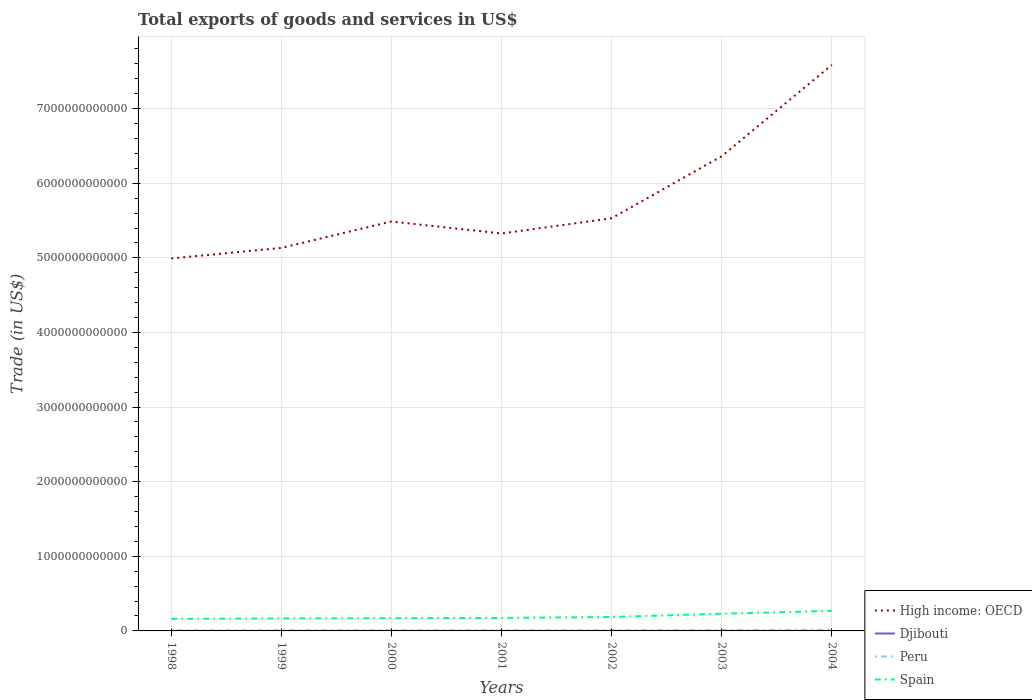Across all years, what is the maximum total exports of goods and services in Peru?
Offer a terse response. 7.54e+09. What is the total total exports of goods and services in Spain in the graph?
Your answer should be compact. -6.36e+1. What is the difference between the highest and the second highest total exports of goods and services in Peru?
Provide a short and direct response. 7.42e+09. What is the difference between the highest and the lowest total exports of goods and services in Djibouti?
Make the answer very short. 3. Is the total exports of goods and services in High income: OECD strictly greater than the total exports of goods and services in Spain over the years?
Offer a terse response. No. What is the difference between two consecutive major ticks on the Y-axis?
Give a very brief answer. 1.00e+12. Does the graph contain any zero values?
Offer a terse response. No. How many legend labels are there?
Provide a short and direct response. 4. What is the title of the graph?
Your response must be concise. Total exports of goods and services in US$. Does "Belize" appear as one of the legend labels in the graph?
Make the answer very short. No. What is the label or title of the Y-axis?
Your answer should be very brief. Trade (in US$). What is the Trade (in US$) of High income: OECD in 1998?
Make the answer very short. 4.99e+12. What is the Trade (in US$) in Djibouti in 1998?
Ensure brevity in your answer.  2.08e+08. What is the Trade (in US$) in Peru in 1998?
Ensure brevity in your answer.  7.54e+09. What is the Trade (in US$) in Spain in 1998?
Your answer should be very brief. 1.62e+11. What is the Trade (in US$) in High income: OECD in 1999?
Provide a succinct answer. 5.13e+12. What is the Trade (in US$) of Djibouti in 1999?
Give a very brief answer. 2.00e+08. What is the Trade (in US$) in Peru in 1999?
Offer a very short reply. 7.64e+09. What is the Trade (in US$) in Spain in 1999?
Provide a short and direct response. 1.67e+11. What is the Trade (in US$) of High income: OECD in 2000?
Provide a succinct answer. 5.49e+12. What is the Trade (in US$) of Djibouti in 2000?
Ensure brevity in your answer.  1.93e+08. What is the Trade (in US$) of Peru in 2000?
Provide a short and direct response. 8.56e+09. What is the Trade (in US$) of Spain in 2000?
Your answer should be very brief. 1.70e+11. What is the Trade (in US$) of High income: OECD in 2001?
Offer a very short reply. 5.33e+12. What is the Trade (in US$) in Djibouti in 2001?
Offer a very short reply. 2.13e+08. What is the Trade (in US$) of Peru in 2001?
Offer a very short reply. 8.50e+09. What is the Trade (in US$) in Spain in 2001?
Ensure brevity in your answer.  1.74e+11. What is the Trade (in US$) of High income: OECD in 2002?
Offer a very short reply. 5.53e+12. What is the Trade (in US$) of Djibouti in 2002?
Provide a short and direct response. 2.28e+08. What is the Trade (in US$) in Peru in 2002?
Your response must be concise. 9.29e+09. What is the Trade (in US$) of Spain in 2002?
Give a very brief answer. 1.87e+11. What is the Trade (in US$) in High income: OECD in 2003?
Ensure brevity in your answer.  6.36e+12. What is the Trade (in US$) of Djibouti in 2003?
Offer a very short reply. 2.48e+08. What is the Trade (in US$) in Peru in 2003?
Keep it short and to the point. 1.09e+1. What is the Trade (in US$) of Spain in 2003?
Your answer should be very brief. 2.31e+11. What is the Trade (in US$) in High income: OECD in 2004?
Give a very brief answer. 7.59e+12. What is the Trade (in US$) in Djibouti in 2004?
Offer a very short reply. 2.46e+08. What is the Trade (in US$) of Peru in 2004?
Ensure brevity in your answer.  1.50e+1. What is the Trade (in US$) in Spain in 2004?
Ensure brevity in your answer.  2.69e+11. Across all years, what is the maximum Trade (in US$) of High income: OECD?
Offer a very short reply. 7.59e+12. Across all years, what is the maximum Trade (in US$) of Djibouti?
Your response must be concise. 2.48e+08. Across all years, what is the maximum Trade (in US$) of Peru?
Your answer should be compact. 1.50e+1. Across all years, what is the maximum Trade (in US$) of Spain?
Your answer should be compact. 2.69e+11. Across all years, what is the minimum Trade (in US$) in High income: OECD?
Your answer should be compact. 4.99e+12. Across all years, what is the minimum Trade (in US$) of Djibouti?
Give a very brief answer. 1.93e+08. Across all years, what is the minimum Trade (in US$) in Peru?
Your response must be concise. 7.54e+09. Across all years, what is the minimum Trade (in US$) of Spain?
Provide a succinct answer. 1.62e+11. What is the total Trade (in US$) of High income: OECD in the graph?
Offer a very short reply. 4.04e+13. What is the total Trade (in US$) of Djibouti in the graph?
Offer a terse response. 1.54e+09. What is the total Trade (in US$) of Peru in the graph?
Your answer should be compact. 6.74e+1. What is the total Trade (in US$) of Spain in the graph?
Offer a very short reply. 1.36e+12. What is the difference between the Trade (in US$) in High income: OECD in 1998 and that in 1999?
Give a very brief answer. -1.42e+11. What is the difference between the Trade (in US$) of Djibouti in 1998 and that in 1999?
Give a very brief answer. 7.96e+06. What is the difference between the Trade (in US$) of Peru in 1998 and that in 1999?
Provide a short and direct response. -1.03e+08. What is the difference between the Trade (in US$) of Spain in 1998 and that in 1999?
Keep it short and to the point. -5.58e+09. What is the difference between the Trade (in US$) of High income: OECD in 1998 and that in 2000?
Offer a very short reply. -4.95e+11. What is the difference between the Trade (in US$) in Djibouti in 1998 and that in 2000?
Your answer should be compact. 1.48e+07. What is the difference between the Trade (in US$) of Peru in 1998 and that in 2000?
Your response must be concise. -1.02e+09. What is the difference between the Trade (in US$) of Spain in 1998 and that in 2000?
Give a very brief answer. -8.82e+09. What is the difference between the Trade (in US$) of High income: OECD in 1998 and that in 2001?
Give a very brief answer. -3.35e+11. What is the difference between the Trade (in US$) in Djibouti in 1998 and that in 2001?
Provide a short and direct response. -5.49e+06. What is the difference between the Trade (in US$) in Peru in 1998 and that in 2001?
Offer a very short reply. -9.64e+08. What is the difference between the Trade (in US$) of Spain in 1998 and that in 2001?
Offer a very short reply. -1.28e+1. What is the difference between the Trade (in US$) in High income: OECD in 1998 and that in 2002?
Your answer should be very brief. -5.39e+11. What is the difference between the Trade (in US$) in Djibouti in 1998 and that in 2002?
Provide a short and direct response. -2.00e+07. What is the difference between the Trade (in US$) in Peru in 1998 and that in 2002?
Ensure brevity in your answer.  -1.75e+09. What is the difference between the Trade (in US$) in Spain in 1998 and that in 2002?
Keep it short and to the point. -2.51e+1. What is the difference between the Trade (in US$) in High income: OECD in 1998 and that in 2003?
Offer a very short reply. -1.37e+12. What is the difference between the Trade (in US$) in Djibouti in 1998 and that in 2003?
Offer a terse response. -4.03e+07. What is the difference between the Trade (in US$) in Peru in 1998 and that in 2003?
Your response must be concise. -3.40e+09. What is the difference between the Trade (in US$) of Spain in 1998 and that in 2003?
Offer a terse response. -6.92e+1. What is the difference between the Trade (in US$) in High income: OECD in 1998 and that in 2004?
Make the answer very short. -2.59e+12. What is the difference between the Trade (in US$) in Djibouti in 1998 and that in 2004?
Your response must be concise. -3.83e+07. What is the difference between the Trade (in US$) of Peru in 1998 and that in 2004?
Offer a terse response. -7.42e+09. What is the difference between the Trade (in US$) in Spain in 1998 and that in 2004?
Your answer should be very brief. -1.08e+11. What is the difference between the Trade (in US$) of High income: OECD in 1999 and that in 2000?
Make the answer very short. -3.53e+11. What is the difference between the Trade (in US$) of Djibouti in 1999 and that in 2000?
Offer a terse response. 6.80e+06. What is the difference between the Trade (in US$) of Peru in 1999 and that in 2000?
Ensure brevity in your answer.  -9.19e+08. What is the difference between the Trade (in US$) of Spain in 1999 and that in 2000?
Give a very brief answer. -3.24e+09. What is the difference between the Trade (in US$) of High income: OECD in 1999 and that in 2001?
Provide a succinct answer. -1.93e+11. What is the difference between the Trade (in US$) of Djibouti in 1999 and that in 2001?
Keep it short and to the point. -1.34e+07. What is the difference between the Trade (in US$) of Peru in 1999 and that in 2001?
Ensure brevity in your answer.  -8.61e+08. What is the difference between the Trade (in US$) of Spain in 1999 and that in 2001?
Your answer should be very brief. -7.26e+09. What is the difference between the Trade (in US$) in High income: OECD in 1999 and that in 2002?
Keep it short and to the point. -3.97e+11. What is the difference between the Trade (in US$) of Djibouti in 1999 and that in 2002?
Make the answer very short. -2.80e+07. What is the difference between the Trade (in US$) in Peru in 1999 and that in 2002?
Provide a succinct answer. -1.65e+09. What is the difference between the Trade (in US$) of Spain in 1999 and that in 2002?
Your answer should be very brief. -1.96e+1. What is the difference between the Trade (in US$) in High income: OECD in 1999 and that in 2003?
Provide a succinct answer. -1.23e+12. What is the difference between the Trade (in US$) of Djibouti in 1999 and that in 2003?
Your answer should be compact. -4.82e+07. What is the difference between the Trade (in US$) of Peru in 1999 and that in 2003?
Ensure brevity in your answer.  -3.30e+09. What is the difference between the Trade (in US$) in Spain in 1999 and that in 2003?
Provide a succinct answer. -6.36e+1. What is the difference between the Trade (in US$) of High income: OECD in 1999 and that in 2004?
Provide a short and direct response. -2.45e+12. What is the difference between the Trade (in US$) in Djibouti in 1999 and that in 2004?
Provide a short and direct response. -4.62e+07. What is the difference between the Trade (in US$) of Peru in 1999 and that in 2004?
Offer a terse response. -7.31e+09. What is the difference between the Trade (in US$) of Spain in 1999 and that in 2004?
Your response must be concise. -1.02e+11. What is the difference between the Trade (in US$) in High income: OECD in 2000 and that in 2001?
Your answer should be very brief. 1.60e+11. What is the difference between the Trade (in US$) in Djibouti in 2000 and that in 2001?
Give a very brief answer. -2.02e+07. What is the difference between the Trade (in US$) in Peru in 2000 and that in 2001?
Give a very brief answer. 5.79e+07. What is the difference between the Trade (in US$) in Spain in 2000 and that in 2001?
Offer a terse response. -4.03e+09. What is the difference between the Trade (in US$) in High income: OECD in 2000 and that in 2002?
Your response must be concise. -4.33e+1. What is the difference between the Trade (in US$) in Djibouti in 2000 and that in 2002?
Give a very brief answer. -3.48e+07. What is the difference between the Trade (in US$) of Peru in 2000 and that in 2002?
Give a very brief answer. -7.33e+08. What is the difference between the Trade (in US$) in Spain in 2000 and that in 2002?
Offer a terse response. -1.63e+1. What is the difference between the Trade (in US$) of High income: OECD in 2000 and that in 2003?
Give a very brief answer. -8.75e+11. What is the difference between the Trade (in US$) in Djibouti in 2000 and that in 2003?
Your answer should be very brief. -5.50e+07. What is the difference between the Trade (in US$) of Peru in 2000 and that in 2003?
Your answer should be very brief. -2.38e+09. What is the difference between the Trade (in US$) of Spain in 2000 and that in 2003?
Offer a terse response. -6.04e+1. What is the difference between the Trade (in US$) in High income: OECD in 2000 and that in 2004?
Make the answer very short. -2.10e+12. What is the difference between the Trade (in US$) of Djibouti in 2000 and that in 2004?
Provide a short and direct response. -5.30e+07. What is the difference between the Trade (in US$) of Peru in 2000 and that in 2004?
Offer a terse response. -6.39e+09. What is the difference between the Trade (in US$) in Spain in 2000 and that in 2004?
Offer a terse response. -9.89e+1. What is the difference between the Trade (in US$) of High income: OECD in 2001 and that in 2002?
Ensure brevity in your answer.  -2.04e+11. What is the difference between the Trade (in US$) in Djibouti in 2001 and that in 2002?
Offer a terse response. -1.45e+07. What is the difference between the Trade (in US$) in Peru in 2001 and that in 2002?
Your response must be concise. -7.90e+08. What is the difference between the Trade (in US$) of Spain in 2001 and that in 2002?
Your response must be concise. -1.23e+1. What is the difference between the Trade (in US$) in High income: OECD in 2001 and that in 2003?
Your response must be concise. -1.04e+12. What is the difference between the Trade (in US$) in Djibouti in 2001 and that in 2003?
Ensure brevity in your answer.  -3.48e+07. What is the difference between the Trade (in US$) of Peru in 2001 and that in 2003?
Your answer should be compact. -2.44e+09. What is the difference between the Trade (in US$) of Spain in 2001 and that in 2003?
Keep it short and to the point. -5.64e+1. What is the difference between the Trade (in US$) in High income: OECD in 2001 and that in 2004?
Offer a terse response. -2.26e+12. What is the difference between the Trade (in US$) of Djibouti in 2001 and that in 2004?
Ensure brevity in your answer.  -3.28e+07. What is the difference between the Trade (in US$) of Peru in 2001 and that in 2004?
Offer a very short reply. -6.45e+09. What is the difference between the Trade (in US$) of Spain in 2001 and that in 2004?
Keep it short and to the point. -9.49e+1. What is the difference between the Trade (in US$) of High income: OECD in 2002 and that in 2003?
Give a very brief answer. -8.32e+11. What is the difference between the Trade (in US$) of Djibouti in 2002 and that in 2003?
Ensure brevity in your answer.  -2.03e+07. What is the difference between the Trade (in US$) in Peru in 2002 and that in 2003?
Provide a succinct answer. -1.65e+09. What is the difference between the Trade (in US$) of Spain in 2002 and that in 2003?
Make the answer very short. -4.41e+1. What is the difference between the Trade (in US$) of High income: OECD in 2002 and that in 2004?
Ensure brevity in your answer.  -2.06e+12. What is the difference between the Trade (in US$) of Djibouti in 2002 and that in 2004?
Your answer should be very brief. -1.82e+07. What is the difference between the Trade (in US$) in Peru in 2002 and that in 2004?
Give a very brief answer. -5.66e+09. What is the difference between the Trade (in US$) in Spain in 2002 and that in 2004?
Give a very brief answer. -8.26e+1. What is the difference between the Trade (in US$) in High income: OECD in 2003 and that in 2004?
Your answer should be very brief. -1.22e+12. What is the difference between the Trade (in US$) in Djibouti in 2003 and that in 2004?
Your answer should be compact. 2.02e+06. What is the difference between the Trade (in US$) of Peru in 2003 and that in 2004?
Offer a terse response. -4.01e+09. What is the difference between the Trade (in US$) in Spain in 2003 and that in 2004?
Ensure brevity in your answer.  -3.85e+1. What is the difference between the Trade (in US$) in High income: OECD in 1998 and the Trade (in US$) in Djibouti in 1999?
Your response must be concise. 4.99e+12. What is the difference between the Trade (in US$) of High income: OECD in 1998 and the Trade (in US$) of Peru in 1999?
Your answer should be very brief. 4.98e+12. What is the difference between the Trade (in US$) in High income: OECD in 1998 and the Trade (in US$) in Spain in 1999?
Offer a very short reply. 4.82e+12. What is the difference between the Trade (in US$) in Djibouti in 1998 and the Trade (in US$) in Peru in 1999?
Provide a succinct answer. -7.43e+09. What is the difference between the Trade (in US$) of Djibouti in 1998 and the Trade (in US$) of Spain in 1999?
Provide a short and direct response. -1.67e+11. What is the difference between the Trade (in US$) in Peru in 1998 and the Trade (in US$) in Spain in 1999?
Provide a short and direct response. -1.60e+11. What is the difference between the Trade (in US$) in High income: OECD in 1998 and the Trade (in US$) in Djibouti in 2000?
Offer a terse response. 4.99e+12. What is the difference between the Trade (in US$) of High income: OECD in 1998 and the Trade (in US$) of Peru in 2000?
Your answer should be very brief. 4.98e+12. What is the difference between the Trade (in US$) in High income: OECD in 1998 and the Trade (in US$) in Spain in 2000?
Provide a short and direct response. 4.82e+12. What is the difference between the Trade (in US$) in Djibouti in 1998 and the Trade (in US$) in Peru in 2000?
Offer a very short reply. -8.35e+09. What is the difference between the Trade (in US$) in Djibouti in 1998 and the Trade (in US$) in Spain in 2000?
Give a very brief answer. -1.70e+11. What is the difference between the Trade (in US$) in Peru in 1998 and the Trade (in US$) in Spain in 2000?
Offer a terse response. -1.63e+11. What is the difference between the Trade (in US$) of High income: OECD in 1998 and the Trade (in US$) of Djibouti in 2001?
Provide a short and direct response. 4.99e+12. What is the difference between the Trade (in US$) in High income: OECD in 1998 and the Trade (in US$) in Peru in 2001?
Give a very brief answer. 4.98e+12. What is the difference between the Trade (in US$) of High income: OECD in 1998 and the Trade (in US$) of Spain in 2001?
Ensure brevity in your answer.  4.82e+12. What is the difference between the Trade (in US$) in Djibouti in 1998 and the Trade (in US$) in Peru in 2001?
Keep it short and to the point. -8.29e+09. What is the difference between the Trade (in US$) of Djibouti in 1998 and the Trade (in US$) of Spain in 2001?
Ensure brevity in your answer.  -1.74e+11. What is the difference between the Trade (in US$) of Peru in 1998 and the Trade (in US$) of Spain in 2001?
Keep it short and to the point. -1.67e+11. What is the difference between the Trade (in US$) of High income: OECD in 1998 and the Trade (in US$) of Djibouti in 2002?
Ensure brevity in your answer.  4.99e+12. What is the difference between the Trade (in US$) of High income: OECD in 1998 and the Trade (in US$) of Peru in 2002?
Make the answer very short. 4.98e+12. What is the difference between the Trade (in US$) in High income: OECD in 1998 and the Trade (in US$) in Spain in 2002?
Your answer should be very brief. 4.80e+12. What is the difference between the Trade (in US$) in Djibouti in 1998 and the Trade (in US$) in Peru in 2002?
Your answer should be compact. -9.08e+09. What is the difference between the Trade (in US$) in Djibouti in 1998 and the Trade (in US$) in Spain in 2002?
Ensure brevity in your answer.  -1.86e+11. What is the difference between the Trade (in US$) in Peru in 1998 and the Trade (in US$) in Spain in 2002?
Your response must be concise. -1.79e+11. What is the difference between the Trade (in US$) of High income: OECD in 1998 and the Trade (in US$) of Djibouti in 2003?
Your answer should be very brief. 4.99e+12. What is the difference between the Trade (in US$) of High income: OECD in 1998 and the Trade (in US$) of Peru in 2003?
Make the answer very short. 4.98e+12. What is the difference between the Trade (in US$) of High income: OECD in 1998 and the Trade (in US$) of Spain in 2003?
Offer a very short reply. 4.76e+12. What is the difference between the Trade (in US$) in Djibouti in 1998 and the Trade (in US$) in Peru in 2003?
Ensure brevity in your answer.  -1.07e+1. What is the difference between the Trade (in US$) in Djibouti in 1998 and the Trade (in US$) in Spain in 2003?
Give a very brief answer. -2.31e+11. What is the difference between the Trade (in US$) in Peru in 1998 and the Trade (in US$) in Spain in 2003?
Offer a terse response. -2.23e+11. What is the difference between the Trade (in US$) in High income: OECD in 1998 and the Trade (in US$) in Djibouti in 2004?
Offer a terse response. 4.99e+12. What is the difference between the Trade (in US$) of High income: OECD in 1998 and the Trade (in US$) of Peru in 2004?
Make the answer very short. 4.98e+12. What is the difference between the Trade (in US$) in High income: OECD in 1998 and the Trade (in US$) in Spain in 2004?
Provide a succinct answer. 4.72e+12. What is the difference between the Trade (in US$) in Djibouti in 1998 and the Trade (in US$) in Peru in 2004?
Offer a very short reply. -1.47e+1. What is the difference between the Trade (in US$) in Djibouti in 1998 and the Trade (in US$) in Spain in 2004?
Keep it short and to the point. -2.69e+11. What is the difference between the Trade (in US$) of Peru in 1998 and the Trade (in US$) of Spain in 2004?
Provide a succinct answer. -2.62e+11. What is the difference between the Trade (in US$) of High income: OECD in 1999 and the Trade (in US$) of Djibouti in 2000?
Keep it short and to the point. 5.13e+12. What is the difference between the Trade (in US$) of High income: OECD in 1999 and the Trade (in US$) of Peru in 2000?
Keep it short and to the point. 5.13e+12. What is the difference between the Trade (in US$) of High income: OECD in 1999 and the Trade (in US$) of Spain in 2000?
Give a very brief answer. 4.96e+12. What is the difference between the Trade (in US$) of Djibouti in 1999 and the Trade (in US$) of Peru in 2000?
Offer a very short reply. -8.36e+09. What is the difference between the Trade (in US$) of Djibouti in 1999 and the Trade (in US$) of Spain in 2000?
Keep it short and to the point. -1.70e+11. What is the difference between the Trade (in US$) in Peru in 1999 and the Trade (in US$) in Spain in 2000?
Keep it short and to the point. -1.63e+11. What is the difference between the Trade (in US$) in High income: OECD in 1999 and the Trade (in US$) in Djibouti in 2001?
Offer a very short reply. 5.13e+12. What is the difference between the Trade (in US$) in High income: OECD in 1999 and the Trade (in US$) in Peru in 2001?
Your answer should be very brief. 5.13e+12. What is the difference between the Trade (in US$) in High income: OECD in 1999 and the Trade (in US$) in Spain in 2001?
Provide a short and direct response. 4.96e+12. What is the difference between the Trade (in US$) in Djibouti in 1999 and the Trade (in US$) in Peru in 2001?
Ensure brevity in your answer.  -8.30e+09. What is the difference between the Trade (in US$) in Djibouti in 1999 and the Trade (in US$) in Spain in 2001?
Your answer should be very brief. -1.74e+11. What is the difference between the Trade (in US$) in Peru in 1999 and the Trade (in US$) in Spain in 2001?
Give a very brief answer. -1.67e+11. What is the difference between the Trade (in US$) in High income: OECD in 1999 and the Trade (in US$) in Djibouti in 2002?
Provide a succinct answer. 5.13e+12. What is the difference between the Trade (in US$) of High income: OECD in 1999 and the Trade (in US$) of Peru in 2002?
Offer a terse response. 5.12e+12. What is the difference between the Trade (in US$) in High income: OECD in 1999 and the Trade (in US$) in Spain in 2002?
Your answer should be compact. 4.95e+12. What is the difference between the Trade (in US$) in Djibouti in 1999 and the Trade (in US$) in Peru in 2002?
Keep it short and to the point. -9.09e+09. What is the difference between the Trade (in US$) in Djibouti in 1999 and the Trade (in US$) in Spain in 2002?
Your response must be concise. -1.87e+11. What is the difference between the Trade (in US$) in Peru in 1999 and the Trade (in US$) in Spain in 2002?
Give a very brief answer. -1.79e+11. What is the difference between the Trade (in US$) in High income: OECD in 1999 and the Trade (in US$) in Djibouti in 2003?
Your response must be concise. 5.13e+12. What is the difference between the Trade (in US$) in High income: OECD in 1999 and the Trade (in US$) in Peru in 2003?
Make the answer very short. 5.12e+12. What is the difference between the Trade (in US$) in High income: OECD in 1999 and the Trade (in US$) in Spain in 2003?
Ensure brevity in your answer.  4.90e+12. What is the difference between the Trade (in US$) in Djibouti in 1999 and the Trade (in US$) in Peru in 2003?
Make the answer very short. -1.07e+1. What is the difference between the Trade (in US$) in Djibouti in 1999 and the Trade (in US$) in Spain in 2003?
Provide a succinct answer. -2.31e+11. What is the difference between the Trade (in US$) of Peru in 1999 and the Trade (in US$) of Spain in 2003?
Offer a terse response. -2.23e+11. What is the difference between the Trade (in US$) of High income: OECD in 1999 and the Trade (in US$) of Djibouti in 2004?
Give a very brief answer. 5.13e+12. What is the difference between the Trade (in US$) of High income: OECD in 1999 and the Trade (in US$) of Peru in 2004?
Keep it short and to the point. 5.12e+12. What is the difference between the Trade (in US$) in High income: OECD in 1999 and the Trade (in US$) in Spain in 2004?
Keep it short and to the point. 4.86e+12. What is the difference between the Trade (in US$) in Djibouti in 1999 and the Trade (in US$) in Peru in 2004?
Give a very brief answer. -1.48e+1. What is the difference between the Trade (in US$) of Djibouti in 1999 and the Trade (in US$) of Spain in 2004?
Give a very brief answer. -2.69e+11. What is the difference between the Trade (in US$) of Peru in 1999 and the Trade (in US$) of Spain in 2004?
Keep it short and to the point. -2.62e+11. What is the difference between the Trade (in US$) in High income: OECD in 2000 and the Trade (in US$) in Djibouti in 2001?
Ensure brevity in your answer.  5.49e+12. What is the difference between the Trade (in US$) in High income: OECD in 2000 and the Trade (in US$) in Peru in 2001?
Your answer should be compact. 5.48e+12. What is the difference between the Trade (in US$) in High income: OECD in 2000 and the Trade (in US$) in Spain in 2001?
Offer a very short reply. 5.31e+12. What is the difference between the Trade (in US$) in Djibouti in 2000 and the Trade (in US$) in Peru in 2001?
Your response must be concise. -8.31e+09. What is the difference between the Trade (in US$) in Djibouti in 2000 and the Trade (in US$) in Spain in 2001?
Provide a short and direct response. -1.74e+11. What is the difference between the Trade (in US$) in Peru in 2000 and the Trade (in US$) in Spain in 2001?
Provide a short and direct response. -1.66e+11. What is the difference between the Trade (in US$) of High income: OECD in 2000 and the Trade (in US$) of Djibouti in 2002?
Offer a terse response. 5.49e+12. What is the difference between the Trade (in US$) of High income: OECD in 2000 and the Trade (in US$) of Peru in 2002?
Offer a very short reply. 5.48e+12. What is the difference between the Trade (in US$) of High income: OECD in 2000 and the Trade (in US$) of Spain in 2002?
Offer a very short reply. 5.30e+12. What is the difference between the Trade (in US$) of Djibouti in 2000 and the Trade (in US$) of Peru in 2002?
Your answer should be compact. -9.10e+09. What is the difference between the Trade (in US$) in Djibouti in 2000 and the Trade (in US$) in Spain in 2002?
Your answer should be compact. -1.87e+11. What is the difference between the Trade (in US$) in Peru in 2000 and the Trade (in US$) in Spain in 2002?
Keep it short and to the point. -1.78e+11. What is the difference between the Trade (in US$) in High income: OECD in 2000 and the Trade (in US$) in Djibouti in 2003?
Your answer should be very brief. 5.49e+12. What is the difference between the Trade (in US$) of High income: OECD in 2000 and the Trade (in US$) of Peru in 2003?
Provide a succinct answer. 5.48e+12. What is the difference between the Trade (in US$) in High income: OECD in 2000 and the Trade (in US$) in Spain in 2003?
Offer a terse response. 5.26e+12. What is the difference between the Trade (in US$) in Djibouti in 2000 and the Trade (in US$) in Peru in 2003?
Provide a succinct answer. -1.07e+1. What is the difference between the Trade (in US$) in Djibouti in 2000 and the Trade (in US$) in Spain in 2003?
Give a very brief answer. -2.31e+11. What is the difference between the Trade (in US$) in Peru in 2000 and the Trade (in US$) in Spain in 2003?
Ensure brevity in your answer.  -2.22e+11. What is the difference between the Trade (in US$) of High income: OECD in 2000 and the Trade (in US$) of Djibouti in 2004?
Offer a very short reply. 5.49e+12. What is the difference between the Trade (in US$) of High income: OECD in 2000 and the Trade (in US$) of Peru in 2004?
Your answer should be compact. 5.47e+12. What is the difference between the Trade (in US$) in High income: OECD in 2000 and the Trade (in US$) in Spain in 2004?
Your response must be concise. 5.22e+12. What is the difference between the Trade (in US$) in Djibouti in 2000 and the Trade (in US$) in Peru in 2004?
Your response must be concise. -1.48e+1. What is the difference between the Trade (in US$) of Djibouti in 2000 and the Trade (in US$) of Spain in 2004?
Your answer should be compact. -2.69e+11. What is the difference between the Trade (in US$) of Peru in 2000 and the Trade (in US$) of Spain in 2004?
Give a very brief answer. -2.61e+11. What is the difference between the Trade (in US$) in High income: OECD in 2001 and the Trade (in US$) in Djibouti in 2002?
Provide a succinct answer. 5.33e+12. What is the difference between the Trade (in US$) in High income: OECD in 2001 and the Trade (in US$) in Peru in 2002?
Your answer should be compact. 5.32e+12. What is the difference between the Trade (in US$) in High income: OECD in 2001 and the Trade (in US$) in Spain in 2002?
Your response must be concise. 5.14e+12. What is the difference between the Trade (in US$) in Djibouti in 2001 and the Trade (in US$) in Peru in 2002?
Make the answer very short. -9.08e+09. What is the difference between the Trade (in US$) in Djibouti in 2001 and the Trade (in US$) in Spain in 2002?
Offer a very short reply. -1.86e+11. What is the difference between the Trade (in US$) in Peru in 2001 and the Trade (in US$) in Spain in 2002?
Your answer should be very brief. -1.78e+11. What is the difference between the Trade (in US$) of High income: OECD in 2001 and the Trade (in US$) of Djibouti in 2003?
Offer a very short reply. 5.33e+12. What is the difference between the Trade (in US$) of High income: OECD in 2001 and the Trade (in US$) of Peru in 2003?
Make the answer very short. 5.32e+12. What is the difference between the Trade (in US$) of High income: OECD in 2001 and the Trade (in US$) of Spain in 2003?
Provide a succinct answer. 5.10e+12. What is the difference between the Trade (in US$) of Djibouti in 2001 and the Trade (in US$) of Peru in 2003?
Give a very brief answer. -1.07e+1. What is the difference between the Trade (in US$) of Djibouti in 2001 and the Trade (in US$) of Spain in 2003?
Provide a succinct answer. -2.31e+11. What is the difference between the Trade (in US$) in Peru in 2001 and the Trade (in US$) in Spain in 2003?
Your answer should be compact. -2.22e+11. What is the difference between the Trade (in US$) in High income: OECD in 2001 and the Trade (in US$) in Djibouti in 2004?
Provide a short and direct response. 5.33e+12. What is the difference between the Trade (in US$) in High income: OECD in 2001 and the Trade (in US$) in Peru in 2004?
Provide a short and direct response. 5.31e+12. What is the difference between the Trade (in US$) of High income: OECD in 2001 and the Trade (in US$) of Spain in 2004?
Your answer should be compact. 5.06e+12. What is the difference between the Trade (in US$) in Djibouti in 2001 and the Trade (in US$) in Peru in 2004?
Offer a very short reply. -1.47e+1. What is the difference between the Trade (in US$) of Djibouti in 2001 and the Trade (in US$) of Spain in 2004?
Provide a short and direct response. -2.69e+11. What is the difference between the Trade (in US$) in Peru in 2001 and the Trade (in US$) in Spain in 2004?
Your response must be concise. -2.61e+11. What is the difference between the Trade (in US$) in High income: OECD in 2002 and the Trade (in US$) in Djibouti in 2003?
Your response must be concise. 5.53e+12. What is the difference between the Trade (in US$) of High income: OECD in 2002 and the Trade (in US$) of Peru in 2003?
Your response must be concise. 5.52e+12. What is the difference between the Trade (in US$) of High income: OECD in 2002 and the Trade (in US$) of Spain in 2003?
Ensure brevity in your answer.  5.30e+12. What is the difference between the Trade (in US$) in Djibouti in 2002 and the Trade (in US$) in Peru in 2003?
Your answer should be compact. -1.07e+1. What is the difference between the Trade (in US$) in Djibouti in 2002 and the Trade (in US$) in Spain in 2003?
Keep it short and to the point. -2.31e+11. What is the difference between the Trade (in US$) of Peru in 2002 and the Trade (in US$) of Spain in 2003?
Your response must be concise. -2.21e+11. What is the difference between the Trade (in US$) of High income: OECD in 2002 and the Trade (in US$) of Djibouti in 2004?
Give a very brief answer. 5.53e+12. What is the difference between the Trade (in US$) of High income: OECD in 2002 and the Trade (in US$) of Peru in 2004?
Make the answer very short. 5.52e+12. What is the difference between the Trade (in US$) of High income: OECD in 2002 and the Trade (in US$) of Spain in 2004?
Provide a succinct answer. 5.26e+12. What is the difference between the Trade (in US$) of Djibouti in 2002 and the Trade (in US$) of Peru in 2004?
Your answer should be very brief. -1.47e+1. What is the difference between the Trade (in US$) of Djibouti in 2002 and the Trade (in US$) of Spain in 2004?
Offer a very short reply. -2.69e+11. What is the difference between the Trade (in US$) in Peru in 2002 and the Trade (in US$) in Spain in 2004?
Make the answer very short. -2.60e+11. What is the difference between the Trade (in US$) of High income: OECD in 2003 and the Trade (in US$) of Djibouti in 2004?
Your answer should be compact. 6.36e+12. What is the difference between the Trade (in US$) of High income: OECD in 2003 and the Trade (in US$) of Peru in 2004?
Keep it short and to the point. 6.35e+12. What is the difference between the Trade (in US$) in High income: OECD in 2003 and the Trade (in US$) in Spain in 2004?
Ensure brevity in your answer.  6.09e+12. What is the difference between the Trade (in US$) of Djibouti in 2003 and the Trade (in US$) of Peru in 2004?
Make the answer very short. -1.47e+1. What is the difference between the Trade (in US$) of Djibouti in 2003 and the Trade (in US$) of Spain in 2004?
Offer a very short reply. -2.69e+11. What is the difference between the Trade (in US$) in Peru in 2003 and the Trade (in US$) in Spain in 2004?
Provide a short and direct response. -2.58e+11. What is the average Trade (in US$) of High income: OECD per year?
Give a very brief answer. 5.77e+12. What is the average Trade (in US$) of Djibouti per year?
Offer a very short reply. 2.20e+08. What is the average Trade (in US$) in Peru per year?
Keep it short and to the point. 9.63e+09. What is the average Trade (in US$) of Spain per year?
Offer a very short reply. 1.94e+11. In the year 1998, what is the difference between the Trade (in US$) of High income: OECD and Trade (in US$) of Djibouti?
Ensure brevity in your answer.  4.99e+12. In the year 1998, what is the difference between the Trade (in US$) of High income: OECD and Trade (in US$) of Peru?
Your answer should be compact. 4.98e+12. In the year 1998, what is the difference between the Trade (in US$) of High income: OECD and Trade (in US$) of Spain?
Provide a succinct answer. 4.83e+12. In the year 1998, what is the difference between the Trade (in US$) in Djibouti and Trade (in US$) in Peru?
Offer a very short reply. -7.33e+09. In the year 1998, what is the difference between the Trade (in US$) of Djibouti and Trade (in US$) of Spain?
Your answer should be compact. -1.61e+11. In the year 1998, what is the difference between the Trade (in US$) in Peru and Trade (in US$) in Spain?
Provide a succinct answer. -1.54e+11. In the year 1999, what is the difference between the Trade (in US$) in High income: OECD and Trade (in US$) in Djibouti?
Make the answer very short. 5.13e+12. In the year 1999, what is the difference between the Trade (in US$) of High income: OECD and Trade (in US$) of Peru?
Ensure brevity in your answer.  5.13e+12. In the year 1999, what is the difference between the Trade (in US$) in High income: OECD and Trade (in US$) in Spain?
Offer a terse response. 4.97e+12. In the year 1999, what is the difference between the Trade (in US$) of Djibouti and Trade (in US$) of Peru?
Make the answer very short. -7.44e+09. In the year 1999, what is the difference between the Trade (in US$) in Djibouti and Trade (in US$) in Spain?
Offer a terse response. -1.67e+11. In the year 1999, what is the difference between the Trade (in US$) of Peru and Trade (in US$) of Spain?
Offer a terse response. -1.60e+11. In the year 2000, what is the difference between the Trade (in US$) in High income: OECD and Trade (in US$) in Djibouti?
Make the answer very short. 5.49e+12. In the year 2000, what is the difference between the Trade (in US$) of High income: OECD and Trade (in US$) of Peru?
Your response must be concise. 5.48e+12. In the year 2000, what is the difference between the Trade (in US$) in High income: OECD and Trade (in US$) in Spain?
Provide a succinct answer. 5.32e+12. In the year 2000, what is the difference between the Trade (in US$) in Djibouti and Trade (in US$) in Peru?
Your answer should be compact. -8.36e+09. In the year 2000, what is the difference between the Trade (in US$) in Djibouti and Trade (in US$) in Spain?
Your answer should be very brief. -1.70e+11. In the year 2000, what is the difference between the Trade (in US$) in Peru and Trade (in US$) in Spain?
Your response must be concise. -1.62e+11. In the year 2001, what is the difference between the Trade (in US$) in High income: OECD and Trade (in US$) in Djibouti?
Offer a terse response. 5.33e+12. In the year 2001, what is the difference between the Trade (in US$) of High income: OECD and Trade (in US$) of Peru?
Make the answer very short. 5.32e+12. In the year 2001, what is the difference between the Trade (in US$) of High income: OECD and Trade (in US$) of Spain?
Ensure brevity in your answer.  5.15e+12. In the year 2001, what is the difference between the Trade (in US$) in Djibouti and Trade (in US$) in Peru?
Keep it short and to the point. -8.29e+09. In the year 2001, what is the difference between the Trade (in US$) in Djibouti and Trade (in US$) in Spain?
Keep it short and to the point. -1.74e+11. In the year 2001, what is the difference between the Trade (in US$) in Peru and Trade (in US$) in Spain?
Give a very brief answer. -1.66e+11. In the year 2002, what is the difference between the Trade (in US$) in High income: OECD and Trade (in US$) in Djibouti?
Keep it short and to the point. 5.53e+12. In the year 2002, what is the difference between the Trade (in US$) of High income: OECD and Trade (in US$) of Peru?
Your answer should be compact. 5.52e+12. In the year 2002, what is the difference between the Trade (in US$) of High income: OECD and Trade (in US$) of Spain?
Your response must be concise. 5.34e+12. In the year 2002, what is the difference between the Trade (in US$) of Djibouti and Trade (in US$) of Peru?
Provide a succinct answer. -9.06e+09. In the year 2002, what is the difference between the Trade (in US$) in Djibouti and Trade (in US$) in Spain?
Provide a succinct answer. -1.86e+11. In the year 2002, what is the difference between the Trade (in US$) in Peru and Trade (in US$) in Spain?
Offer a terse response. -1.77e+11. In the year 2003, what is the difference between the Trade (in US$) of High income: OECD and Trade (in US$) of Djibouti?
Provide a succinct answer. 6.36e+12. In the year 2003, what is the difference between the Trade (in US$) of High income: OECD and Trade (in US$) of Peru?
Your answer should be very brief. 6.35e+12. In the year 2003, what is the difference between the Trade (in US$) in High income: OECD and Trade (in US$) in Spain?
Give a very brief answer. 6.13e+12. In the year 2003, what is the difference between the Trade (in US$) of Djibouti and Trade (in US$) of Peru?
Your answer should be compact. -1.07e+1. In the year 2003, what is the difference between the Trade (in US$) in Djibouti and Trade (in US$) in Spain?
Ensure brevity in your answer.  -2.31e+11. In the year 2003, what is the difference between the Trade (in US$) in Peru and Trade (in US$) in Spain?
Ensure brevity in your answer.  -2.20e+11. In the year 2004, what is the difference between the Trade (in US$) of High income: OECD and Trade (in US$) of Djibouti?
Provide a short and direct response. 7.59e+12. In the year 2004, what is the difference between the Trade (in US$) in High income: OECD and Trade (in US$) in Peru?
Your answer should be very brief. 7.57e+12. In the year 2004, what is the difference between the Trade (in US$) in High income: OECD and Trade (in US$) in Spain?
Give a very brief answer. 7.32e+12. In the year 2004, what is the difference between the Trade (in US$) of Djibouti and Trade (in US$) of Peru?
Keep it short and to the point. -1.47e+1. In the year 2004, what is the difference between the Trade (in US$) of Djibouti and Trade (in US$) of Spain?
Ensure brevity in your answer.  -2.69e+11. In the year 2004, what is the difference between the Trade (in US$) in Peru and Trade (in US$) in Spain?
Your answer should be compact. -2.54e+11. What is the ratio of the Trade (in US$) of High income: OECD in 1998 to that in 1999?
Your answer should be compact. 0.97. What is the ratio of the Trade (in US$) in Djibouti in 1998 to that in 1999?
Offer a terse response. 1.04. What is the ratio of the Trade (in US$) of Peru in 1998 to that in 1999?
Offer a very short reply. 0.99. What is the ratio of the Trade (in US$) in Spain in 1998 to that in 1999?
Your response must be concise. 0.97. What is the ratio of the Trade (in US$) in High income: OECD in 1998 to that in 2000?
Offer a very short reply. 0.91. What is the ratio of the Trade (in US$) in Djibouti in 1998 to that in 2000?
Provide a short and direct response. 1.08. What is the ratio of the Trade (in US$) of Peru in 1998 to that in 2000?
Make the answer very short. 0.88. What is the ratio of the Trade (in US$) in Spain in 1998 to that in 2000?
Provide a short and direct response. 0.95. What is the ratio of the Trade (in US$) in High income: OECD in 1998 to that in 2001?
Keep it short and to the point. 0.94. What is the ratio of the Trade (in US$) of Djibouti in 1998 to that in 2001?
Give a very brief answer. 0.97. What is the ratio of the Trade (in US$) in Peru in 1998 to that in 2001?
Offer a very short reply. 0.89. What is the ratio of the Trade (in US$) of Spain in 1998 to that in 2001?
Offer a very short reply. 0.93. What is the ratio of the Trade (in US$) in High income: OECD in 1998 to that in 2002?
Your response must be concise. 0.9. What is the ratio of the Trade (in US$) in Djibouti in 1998 to that in 2002?
Provide a short and direct response. 0.91. What is the ratio of the Trade (in US$) of Peru in 1998 to that in 2002?
Ensure brevity in your answer.  0.81. What is the ratio of the Trade (in US$) of Spain in 1998 to that in 2002?
Keep it short and to the point. 0.87. What is the ratio of the Trade (in US$) in High income: OECD in 1998 to that in 2003?
Keep it short and to the point. 0.78. What is the ratio of the Trade (in US$) of Djibouti in 1998 to that in 2003?
Provide a short and direct response. 0.84. What is the ratio of the Trade (in US$) of Peru in 1998 to that in 2003?
Your response must be concise. 0.69. What is the ratio of the Trade (in US$) of Spain in 1998 to that in 2003?
Provide a succinct answer. 0.7. What is the ratio of the Trade (in US$) of High income: OECD in 1998 to that in 2004?
Your answer should be compact. 0.66. What is the ratio of the Trade (in US$) of Djibouti in 1998 to that in 2004?
Keep it short and to the point. 0.84. What is the ratio of the Trade (in US$) of Peru in 1998 to that in 2004?
Provide a short and direct response. 0.5. What is the ratio of the Trade (in US$) in Spain in 1998 to that in 2004?
Provide a succinct answer. 0.6. What is the ratio of the Trade (in US$) of High income: OECD in 1999 to that in 2000?
Keep it short and to the point. 0.94. What is the ratio of the Trade (in US$) of Djibouti in 1999 to that in 2000?
Your answer should be very brief. 1.04. What is the ratio of the Trade (in US$) of Peru in 1999 to that in 2000?
Give a very brief answer. 0.89. What is the ratio of the Trade (in US$) of Spain in 1999 to that in 2000?
Provide a short and direct response. 0.98. What is the ratio of the Trade (in US$) in High income: OECD in 1999 to that in 2001?
Your answer should be very brief. 0.96. What is the ratio of the Trade (in US$) of Djibouti in 1999 to that in 2001?
Your answer should be very brief. 0.94. What is the ratio of the Trade (in US$) of Peru in 1999 to that in 2001?
Give a very brief answer. 0.9. What is the ratio of the Trade (in US$) in Spain in 1999 to that in 2001?
Offer a very short reply. 0.96. What is the ratio of the Trade (in US$) in High income: OECD in 1999 to that in 2002?
Your answer should be compact. 0.93. What is the ratio of the Trade (in US$) of Djibouti in 1999 to that in 2002?
Provide a short and direct response. 0.88. What is the ratio of the Trade (in US$) in Peru in 1999 to that in 2002?
Make the answer very short. 0.82. What is the ratio of the Trade (in US$) of Spain in 1999 to that in 2002?
Offer a very short reply. 0.9. What is the ratio of the Trade (in US$) in High income: OECD in 1999 to that in 2003?
Ensure brevity in your answer.  0.81. What is the ratio of the Trade (in US$) of Djibouti in 1999 to that in 2003?
Provide a short and direct response. 0.81. What is the ratio of the Trade (in US$) in Peru in 1999 to that in 2003?
Your answer should be very brief. 0.7. What is the ratio of the Trade (in US$) in Spain in 1999 to that in 2003?
Ensure brevity in your answer.  0.72. What is the ratio of the Trade (in US$) of High income: OECD in 1999 to that in 2004?
Provide a succinct answer. 0.68. What is the ratio of the Trade (in US$) in Djibouti in 1999 to that in 2004?
Your answer should be very brief. 0.81. What is the ratio of the Trade (in US$) of Peru in 1999 to that in 2004?
Offer a very short reply. 0.51. What is the ratio of the Trade (in US$) of Spain in 1999 to that in 2004?
Ensure brevity in your answer.  0.62. What is the ratio of the Trade (in US$) of High income: OECD in 2000 to that in 2001?
Provide a succinct answer. 1.03. What is the ratio of the Trade (in US$) in Djibouti in 2000 to that in 2001?
Keep it short and to the point. 0.91. What is the ratio of the Trade (in US$) in Peru in 2000 to that in 2001?
Ensure brevity in your answer.  1.01. What is the ratio of the Trade (in US$) in Spain in 2000 to that in 2001?
Your answer should be compact. 0.98. What is the ratio of the Trade (in US$) of Djibouti in 2000 to that in 2002?
Make the answer very short. 0.85. What is the ratio of the Trade (in US$) in Peru in 2000 to that in 2002?
Give a very brief answer. 0.92. What is the ratio of the Trade (in US$) of Spain in 2000 to that in 2002?
Offer a terse response. 0.91. What is the ratio of the Trade (in US$) in High income: OECD in 2000 to that in 2003?
Your answer should be very brief. 0.86. What is the ratio of the Trade (in US$) of Djibouti in 2000 to that in 2003?
Provide a short and direct response. 0.78. What is the ratio of the Trade (in US$) in Peru in 2000 to that in 2003?
Make the answer very short. 0.78. What is the ratio of the Trade (in US$) in Spain in 2000 to that in 2003?
Provide a short and direct response. 0.74. What is the ratio of the Trade (in US$) in High income: OECD in 2000 to that in 2004?
Offer a very short reply. 0.72. What is the ratio of the Trade (in US$) of Djibouti in 2000 to that in 2004?
Your answer should be compact. 0.78. What is the ratio of the Trade (in US$) of Peru in 2000 to that in 2004?
Offer a terse response. 0.57. What is the ratio of the Trade (in US$) in Spain in 2000 to that in 2004?
Provide a short and direct response. 0.63. What is the ratio of the Trade (in US$) of High income: OECD in 2001 to that in 2002?
Ensure brevity in your answer.  0.96. What is the ratio of the Trade (in US$) of Djibouti in 2001 to that in 2002?
Provide a succinct answer. 0.94. What is the ratio of the Trade (in US$) of Peru in 2001 to that in 2002?
Your answer should be compact. 0.91. What is the ratio of the Trade (in US$) in Spain in 2001 to that in 2002?
Make the answer very short. 0.93. What is the ratio of the Trade (in US$) of High income: OECD in 2001 to that in 2003?
Ensure brevity in your answer.  0.84. What is the ratio of the Trade (in US$) in Djibouti in 2001 to that in 2003?
Keep it short and to the point. 0.86. What is the ratio of the Trade (in US$) in Peru in 2001 to that in 2003?
Offer a terse response. 0.78. What is the ratio of the Trade (in US$) in Spain in 2001 to that in 2003?
Ensure brevity in your answer.  0.76. What is the ratio of the Trade (in US$) in High income: OECD in 2001 to that in 2004?
Your answer should be very brief. 0.7. What is the ratio of the Trade (in US$) in Djibouti in 2001 to that in 2004?
Provide a succinct answer. 0.87. What is the ratio of the Trade (in US$) of Peru in 2001 to that in 2004?
Keep it short and to the point. 0.57. What is the ratio of the Trade (in US$) in Spain in 2001 to that in 2004?
Provide a short and direct response. 0.65. What is the ratio of the Trade (in US$) in High income: OECD in 2002 to that in 2003?
Make the answer very short. 0.87. What is the ratio of the Trade (in US$) of Djibouti in 2002 to that in 2003?
Provide a succinct answer. 0.92. What is the ratio of the Trade (in US$) of Peru in 2002 to that in 2003?
Your answer should be compact. 0.85. What is the ratio of the Trade (in US$) in Spain in 2002 to that in 2003?
Your answer should be compact. 0.81. What is the ratio of the Trade (in US$) of High income: OECD in 2002 to that in 2004?
Give a very brief answer. 0.73. What is the ratio of the Trade (in US$) in Djibouti in 2002 to that in 2004?
Provide a short and direct response. 0.93. What is the ratio of the Trade (in US$) in Peru in 2002 to that in 2004?
Provide a short and direct response. 0.62. What is the ratio of the Trade (in US$) in Spain in 2002 to that in 2004?
Ensure brevity in your answer.  0.69. What is the ratio of the Trade (in US$) in High income: OECD in 2003 to that in 2004?
Your response must be concise. 0.84. What is the ratio of the Trade (in US$) of Djibouti in 2003 to that in 2004?
Your response must be concise. 1.01. What is the ratio of the Trade (in US$) in Peru in 2003 to that in 2004?
Your answer should be compact. 0.73. What is the ratio of the Trade (in US$) in Spain in 2003 to that in 2004?
Your answer should be compact. 0.86. What is the difference between the highest and the second highest Trade (in US$) of High income: OECD?
Ensure brevity in your answer.  1.22e+12. What is the difference between the highest and the second highest Trade (in US$) in Djibouti?
Ensure brevity in your answer.  2.02e+06. What is the difference between the highest and the second highest Trade (in US$) of Peru?
Offer a very short reply. 4.01e+09. What is the difference between the highest and the second highest Trade (in US$) of Spain?
Make the answer very short. 3.85e+1. What is the difference between the highest and the lowest Trade (in US$) in High income: OECD?
Offer a very short reply. 2.59e+12. What is the difference between the highest and the lowest Trade (in US$) of Djibouti?
Your response must be concise. 5.50e+07. What is the difference between the highest and the lowest Trade (in US$) in Peru?
Provide a short and direct response. 7.42e+09. What is the difference between the highest and the lowest Trade (in US$) in Spain?
Give a very brief answer. 1.08e+11. 